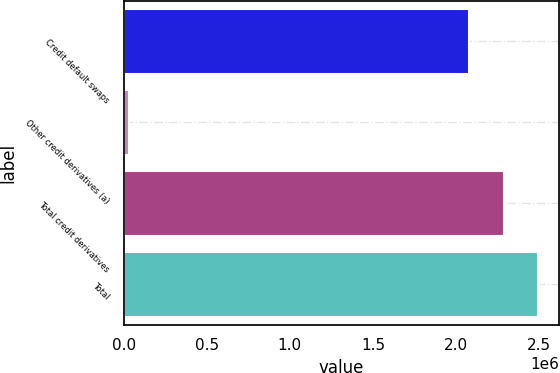Convert chart. <chart><loc_0><loc_0><loc_500><loc_500><bar_chart><fcel>Credit default swaps<fcel>Other credit derivatives (a)<fcel>Total credit derivatives<fcel>Total<nl><fcel>2.0781e+06<fcel>32048<fcel>2.28591e+06<fcel>2.49372e+06<nl></chart> 